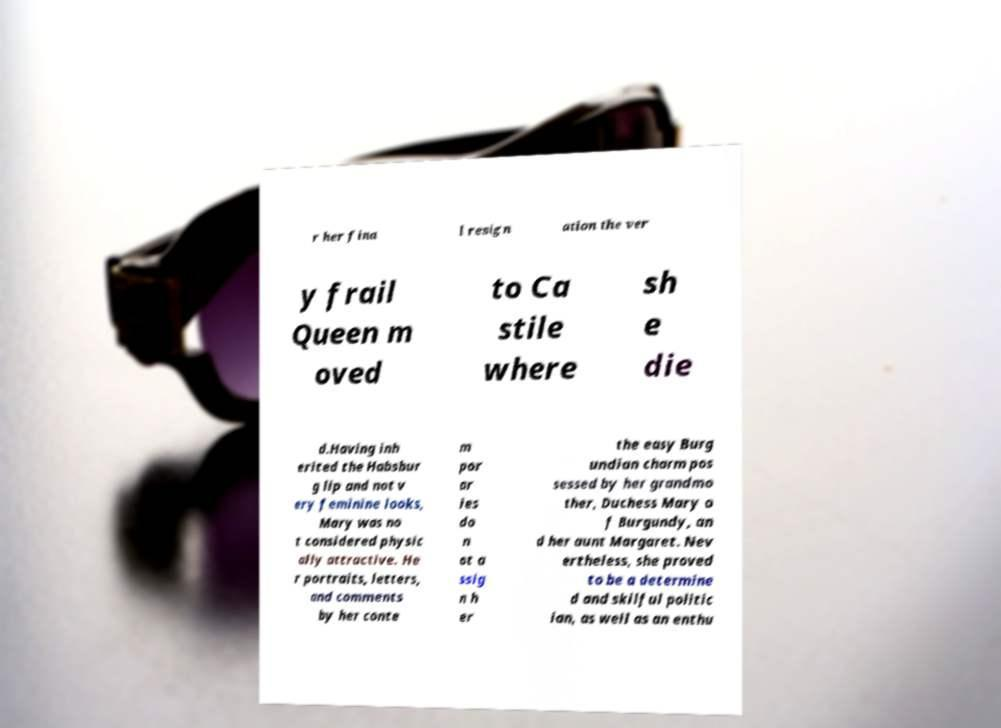For documentation purposes, I need the text within this image transcribed. Could you provide that? r her fina l resign ation the ver y frail Queen m oved to Ca stile where sh e die d.Having inh erited the Habsbur g lip and not v ery feminine looks, Mary was no t considered physic ally attractive. He r portraits, letters, and comments by her conte m por ar ies do n ot a ssig n h er the easy Burg undian charm pos sessed by her grandmo ther, Duchess Mary o f Burgundy, an d her aunt Margaret. Nev ertheless, she proved to be a determine d and skilful politic ian, as well as an enthu 